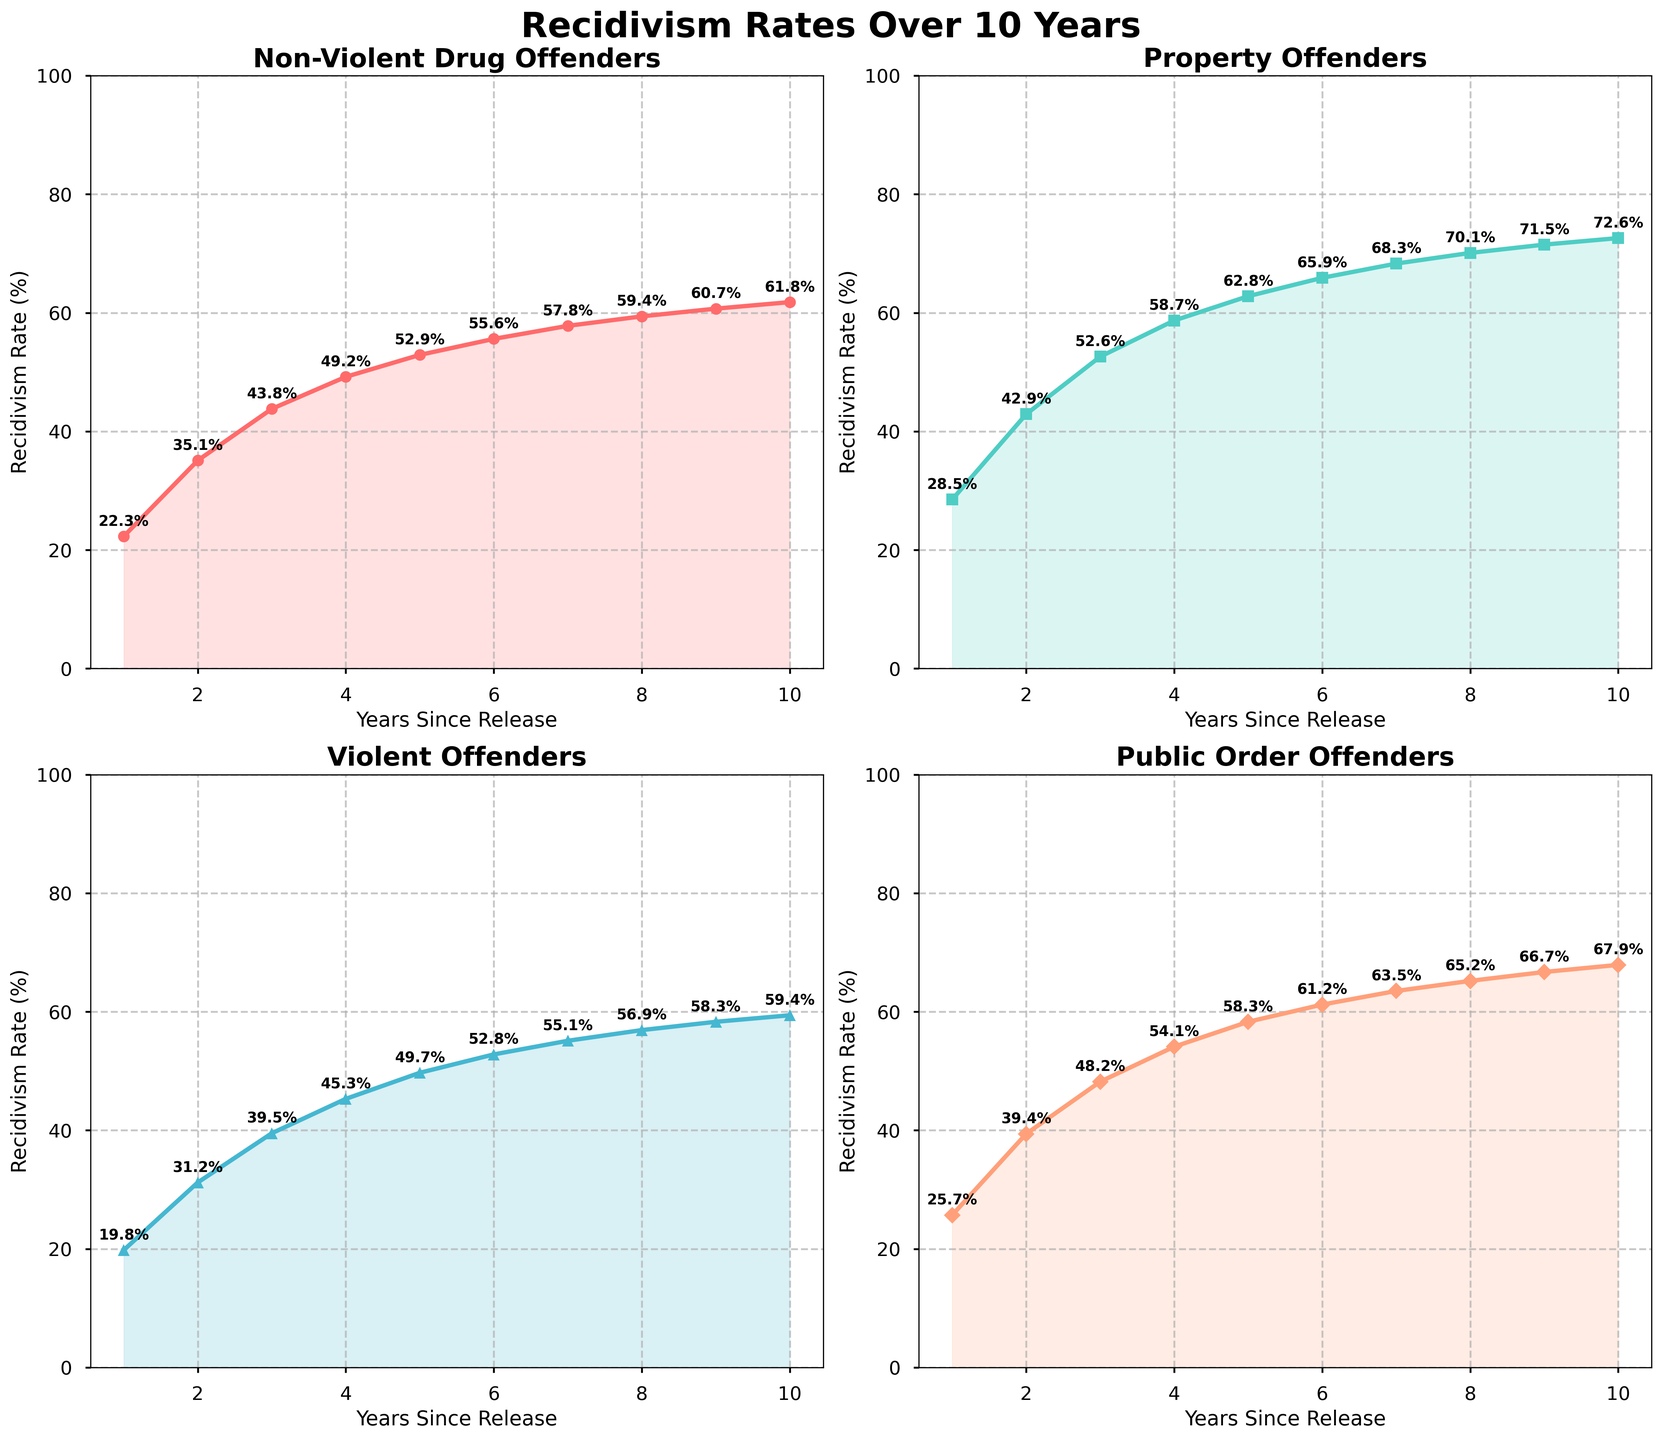What is the recidivism rate for non-violent drug offenders in year 5? By looking at the plot for "Non-Violent Drug Offenders," we can see that the y-value corresponding to year 5 is 52.9%.
Answer: 52.9% Which category shows the highest recidivism rate in year 10? By comparing the plots for all categories in year 10, "Property Offenders" has the highest recidivism rate of 72.6%.
Answer: Property Offenders In which year do non-violent drug offenders have a recidivism rate closer to 60%? Observing the plot for "Non-Violent Drug Offenders," the recidivism rate is 59.4% in year 8 and 60.7% in year 9. Year 9 is closer to 60%.
Answer: Year 9 Compare the recidivism rates of violent offenders and non-violent drug offenders in year 4. Which is higher and by how much? In year 4, "Violent Offenders" have a recidivism rate of 45.3%, and "Non-Violent Drug Offenders" have a rate of 49.2%. The latter is higher by 49.2% - 45.3% = 3.9%.
Answer: Non-Violent Drug Offenders by 3.9% What is the average recidivism rate for public order offenders over the 10-year period? Sum the recidivism rates for "Public Order Offenders" across all years and divide by 10: (25.7 + 39.4 + 48.2 + 54.1 + 58.3 + 61.2 + 63.5 + 65.2 + 66.7 + 67.9) / 10 = 55.92%.
Answer: 55.92% Which category has the least percentage increase in recidivism rate from year 1 to year 10? Calculating the percentage increase for each category:
- Non-Violent Drug Offenders: (61.8 - 22.3) / 22.3 * 100 ≈ 177.1%
- Property Offenders: (72.6 - 28.5) / 28.5 * 100 ≈ 154.7%
- Violent Offenders: (59.4 - 19.8) / 19.8 * 100 ≈ 200.0%
- Public Order Offenders: (67.9 - 25.7) / 25.7 * 100 ≈ 164.2%
Property Offenders have the least percentage increase of 154.7%.
Answer: Property Offenders Which category has the most consistent year-over-year increase in recidivism rate? By analyzing the plots, "Non-Violent Drug Offenders" shows a smooth and steady increase without significant spikes or dips, indicating the most consistent increase.
Answer: Non-Violent Drug Offenders Identify the year when public order offenders first surpass a recidivism rate of 60%. Checking the plot for "Public Order Offenders," they surpass 60% in year 6.
Answer: Year 6 